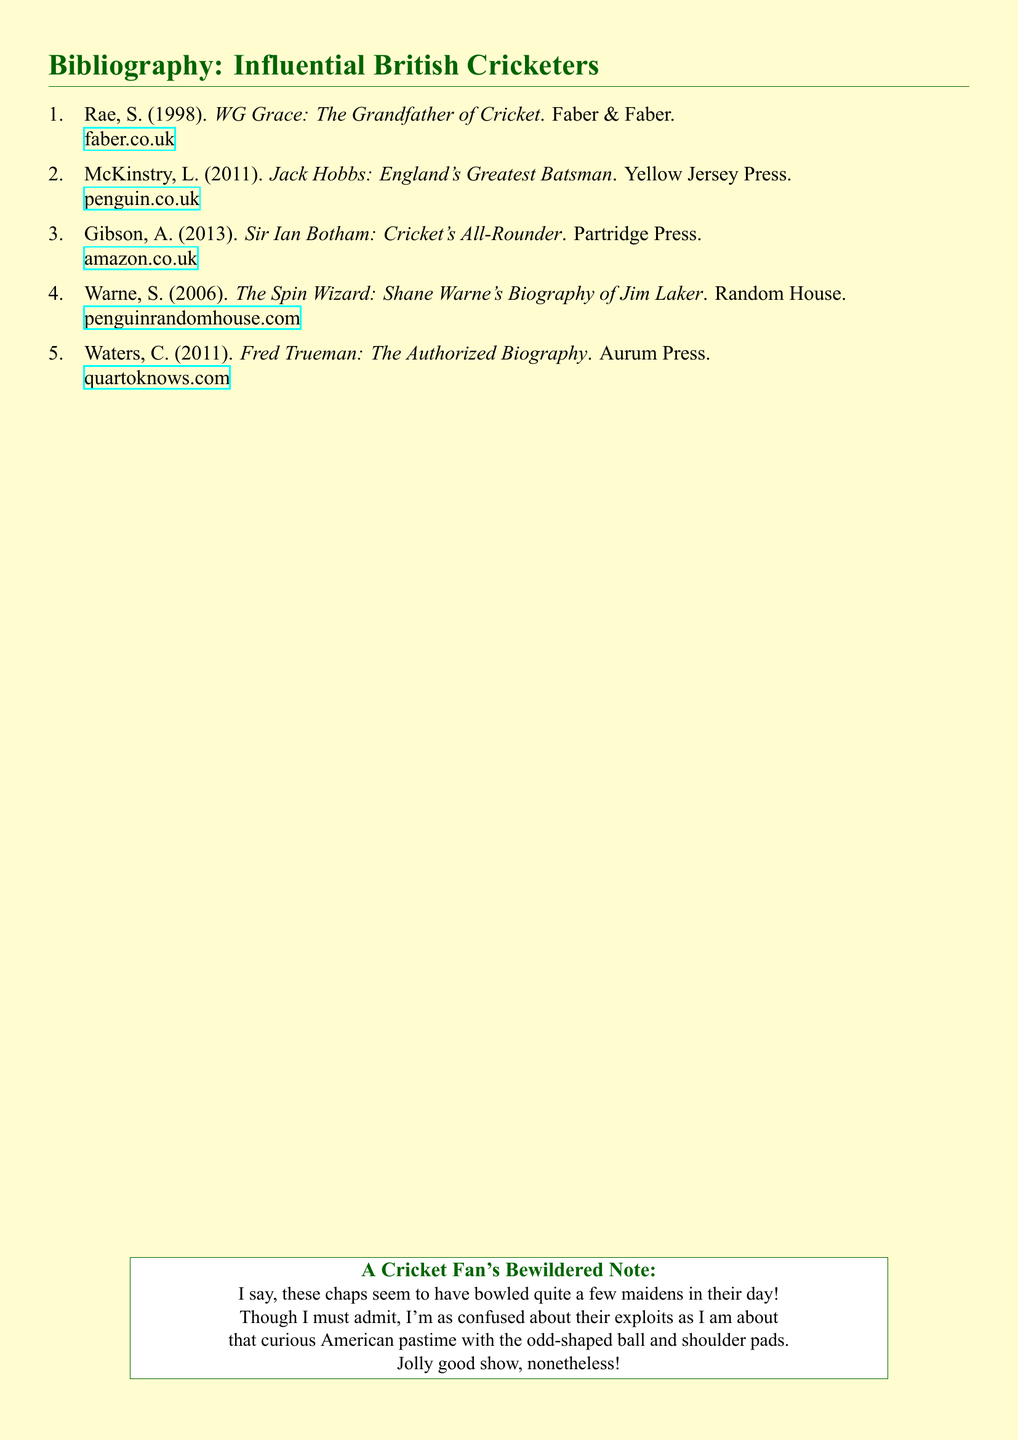What is the title of the first book listed? The title of the first book listed is the one by S. Rae, and it is indicated at the top of the bibliography.
Answer: WG Grace: The Grandfather of Cricket Who wrote the biography of Jack Hobbs? The author of the biography of Jack Hobbs, as stated in the document, is L. McKinstry.
Answer: L. McKinstry What year was the book about Ian Botham published? The publication year of the book about Ian Botham can be found next to the author A. Gibson in the bibliography.
Answer: 2013 Which publisher released the biography of Jim Laker? The publisher of the biography of Jim Laker is mentioned beside the author's name in the document.
Answer: Random House How many biographies are listed in total? The total number of biographies included in the document is indicated by the number of entries in the enumerated list.
Answer: 5 Which cricketer is referred to as "England's Greatest Batsman"? The cricketer referred to as "England's Greatest Batsman" is mentioned in the title of L. McKinstry's biography.
Answer: Jack Hobbs What color is mentioned in the title format for the sections? The color specified for the section titles in the document is highlighted in the formatting commands.
Answer: cricketgreen What is the primary font used in the document? The primary font used in the document can be identified in the fontspec package at the beginning.
Answer: Times New Roman 